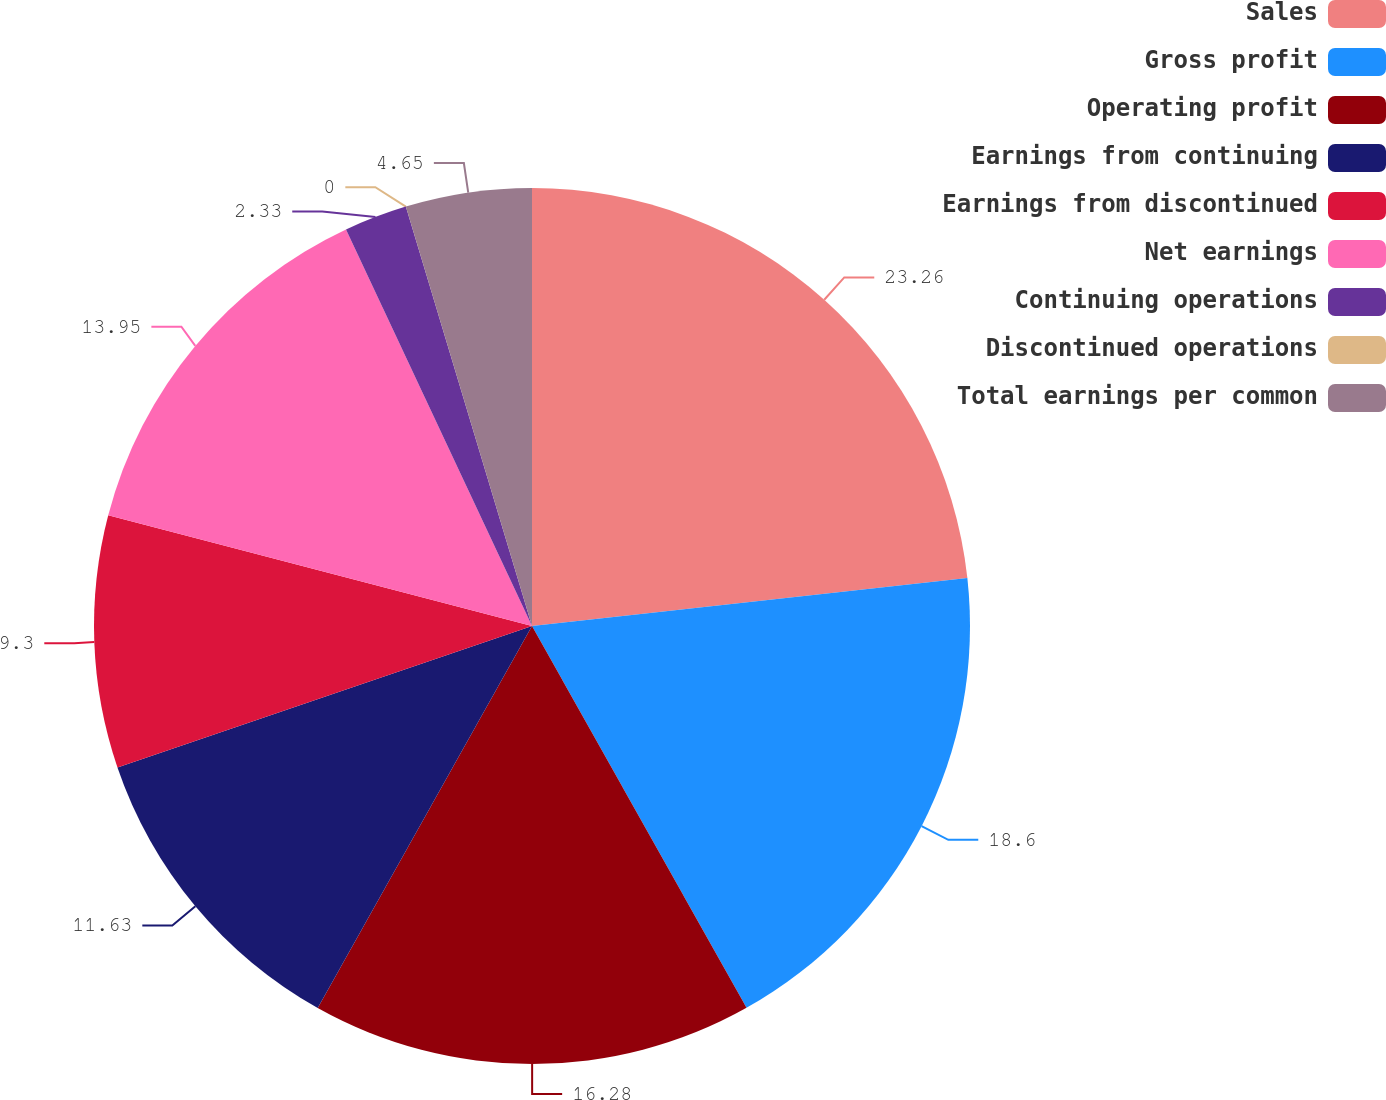Convert chart to OTSL. <chart><loc_0><loc_0><loc_500><loc_500><pie_chart><fcel>Sales<fcel>Gross profit<fcel>Operating profit<fcel>Earnings from continuing<fcel>Earnings from discontinued<fcel>Net earnings<fcel>Continuing operations<fcel>Discontinued operations<fcel>Total earnings per common<nl><fcel>23.25%<fcel>18.6%<fcel>16.28%<fcel>11.63%<fcel>9.3%<fcel>13.95%<fcel>2.33%<fcel>0.0%<fcel>4.65%<nl></chart> 